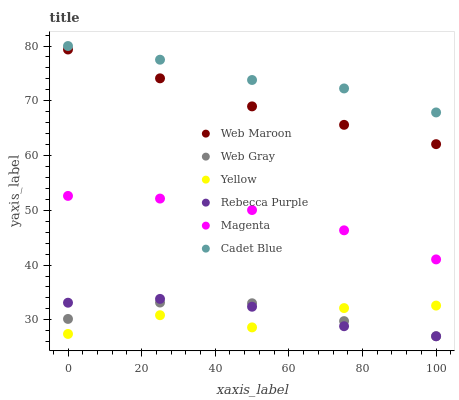Does Yellow have the minimum area under the curve?
Answer yes or no. Yes. Does Cadet Blue have the maximum area under the curve?
Answer yes or no. Yes. Does Web Maroon have the minimum area under the curve?
Answer yes or no. No. Does Web Maroon have the maximum area under the curve?
Answer yes or no. No. Is Web Maroon the smoothest?
Answer yes or no. Yes. Is Yellow the roughest?
Answer yes or no. Yes. Is Yellow the smoothest?
Answer yes or no. No. Is Web Maroon the roughest?
Answer yes or no. No. Does Web Gray have the lowest value?
Answer yes or no. Yes. Does Web Maroon have the lowest value?
Answer yes or no. No. Does Cadet Blue have the highest value?
Answer yes or no. Yes. Does Web Maroon have the highest value?
Answer yes or no. No. Is Yellow less than Web Maroon?
Answer yes or no. Yes. Is Web Maroon greater than Rebecca Purple?
Answer yes or no. Yes. Does Yellow intersect Web Gray?
Answer yes or no. Yes. Is Yellow less than Web Gray?
Answer yes or no. No. Is Yellow greater than Web Gray?
Answer yes or no. No. Does Yellow intersect Web Maroon?
Answer yes or no. No. 